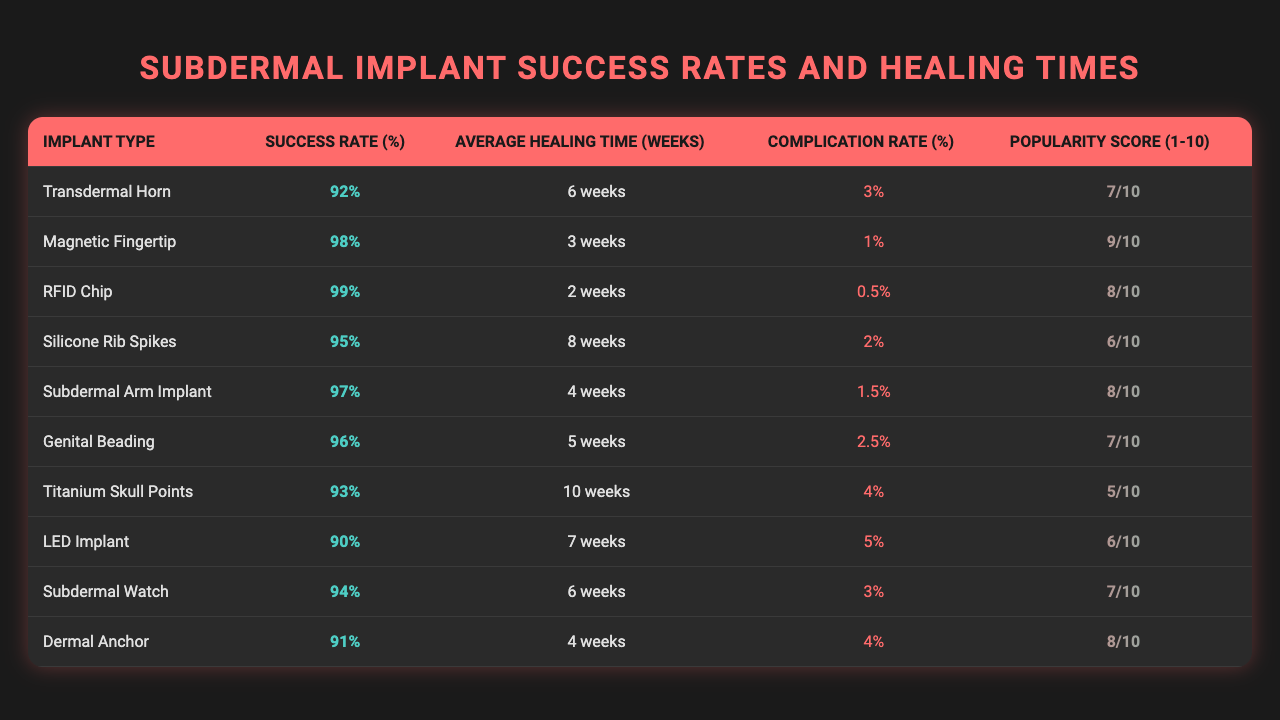What is the success rate of the RFID Chip implant? The RFID Chip's success rate is directly listed in the table under "Success Rate (%)", which shows a value of 99%.
Answer: 99% Which implant type has the highest popularity score? The implant with the highest popularity score is the Magnetic Fingertip, with a score of 9 out of 10.
Answer: Magnetic Fingertip What is the average healing time for the Transdermal Horn and Subdermal Arm Implant combined? To find the average healing time, add the healing times of Transdermal Horn (6 weeks) and Subdermal Arm Implant (4 weeks) to get 10 weeks. Then divide by 2, resulting in an average of 10/2 = 5 weeks.
Answer: 5 weeks Is the complication rate for the LED Implant greater than the complication rate for the Silicone Rib Spikes? The complication rate for the LED Implant is 5%, and for the Silicone Rib Spikes, it is 2%. Since 5% is greater than 2%, the statement is true.
Answer: Yes What is the success rate difference between the Magnetic Fingertip and the Titanium Skull Points implants? The success rate of the Magnetic Fingertip is 98%, and that of the Titanium Skull Points is 93%. The difference is 98% - 93% = 5%.
Answer: 5% What is the average complication rate of all implants listed? To calculate the average complication rate, sum all complication rates (3 + 1 + 0.5 + 2 + 1.5 + 2.5 + 4 + 5 + 3 + 4) = 23. The total number of implants is 10, so the average is 23/10 = 2.3%.
Answer: 2.3% Which implant type has the shortest average healing time? The implant type with the shortest average healing time is the RFID Chip, with an average healing time of 2 weeks, as displayed in the table.
Answer: RFID Chip Is the complication rate for the Genital Beading lower than that of the Dermal Anchor? The complication rate for Genital Beading is 2.5%, while for Dermal Anchor, it is 4%. Since 2.5% is lower than 4%, the statement is true.
Answer: Yes How many implants have a success rate above 95%? The implants with success rates above 95% are the Magnetic Fingertip (98%), RFID Chip (99%), Subdermal Arm Implant (97%), and Genital Beading (96%) — a total of 4 implants.
Answer: 4 What is the relationship between popularity scores and healing times in the table? By exploring the data, we see that there is no direct correlation, as implants with varying healing times can have similar or different popularity scores, indicating a complex relationship not easily defined.
Answer: N/A 